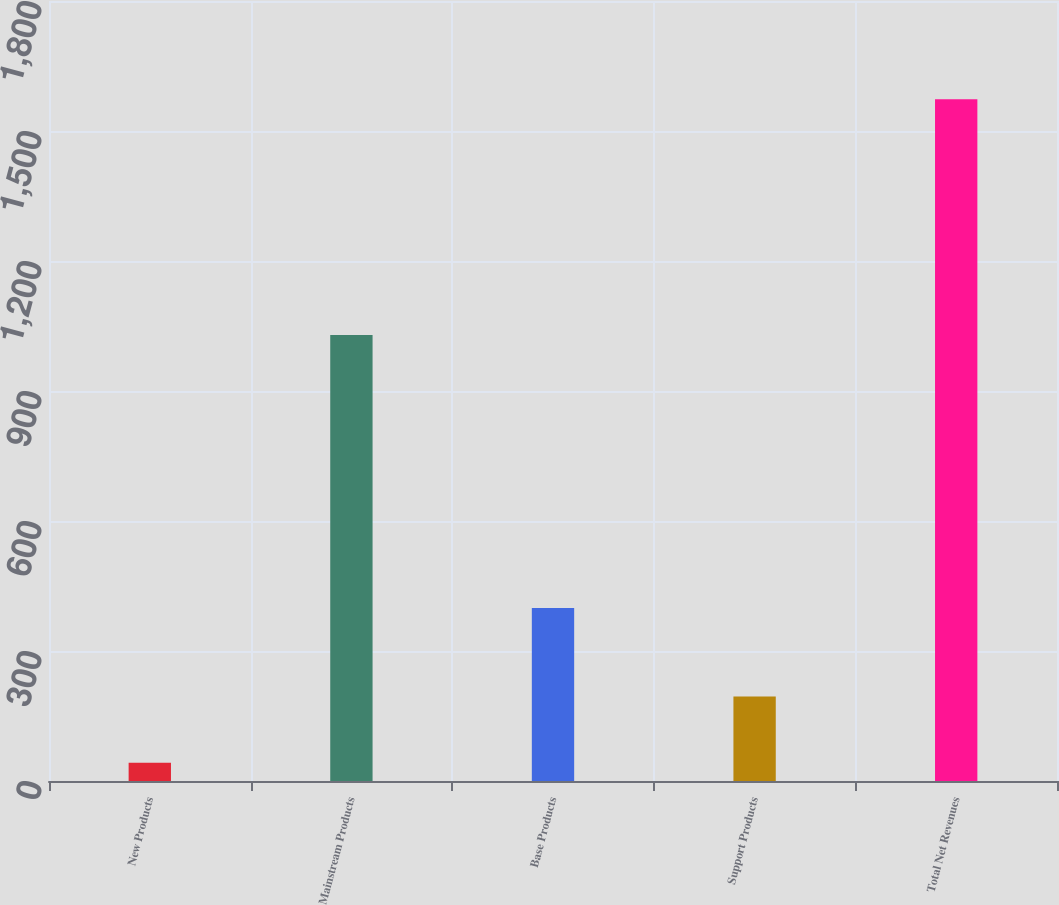<chart> <loc_0><loc_0><loc_500><loc_500><bar_chart><fcel>New Products<fcel>Mainstream Products<fcel>Base Products<fcel>Support Products<fcel>Total Net Revenues<nl><fcel>42.1<fcel>1029<fcel>399.2<fcel>195.21<fcel>1573.2<nl></chart> 